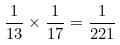Convert formula to latex. <formula><loc_0><loc_0><loc_500><loc_500>\frac { 1 } { 1 3 } \times \frac { 1 } { 1 7 } = \frac { 1 } { 2 2 1 }</formula> 